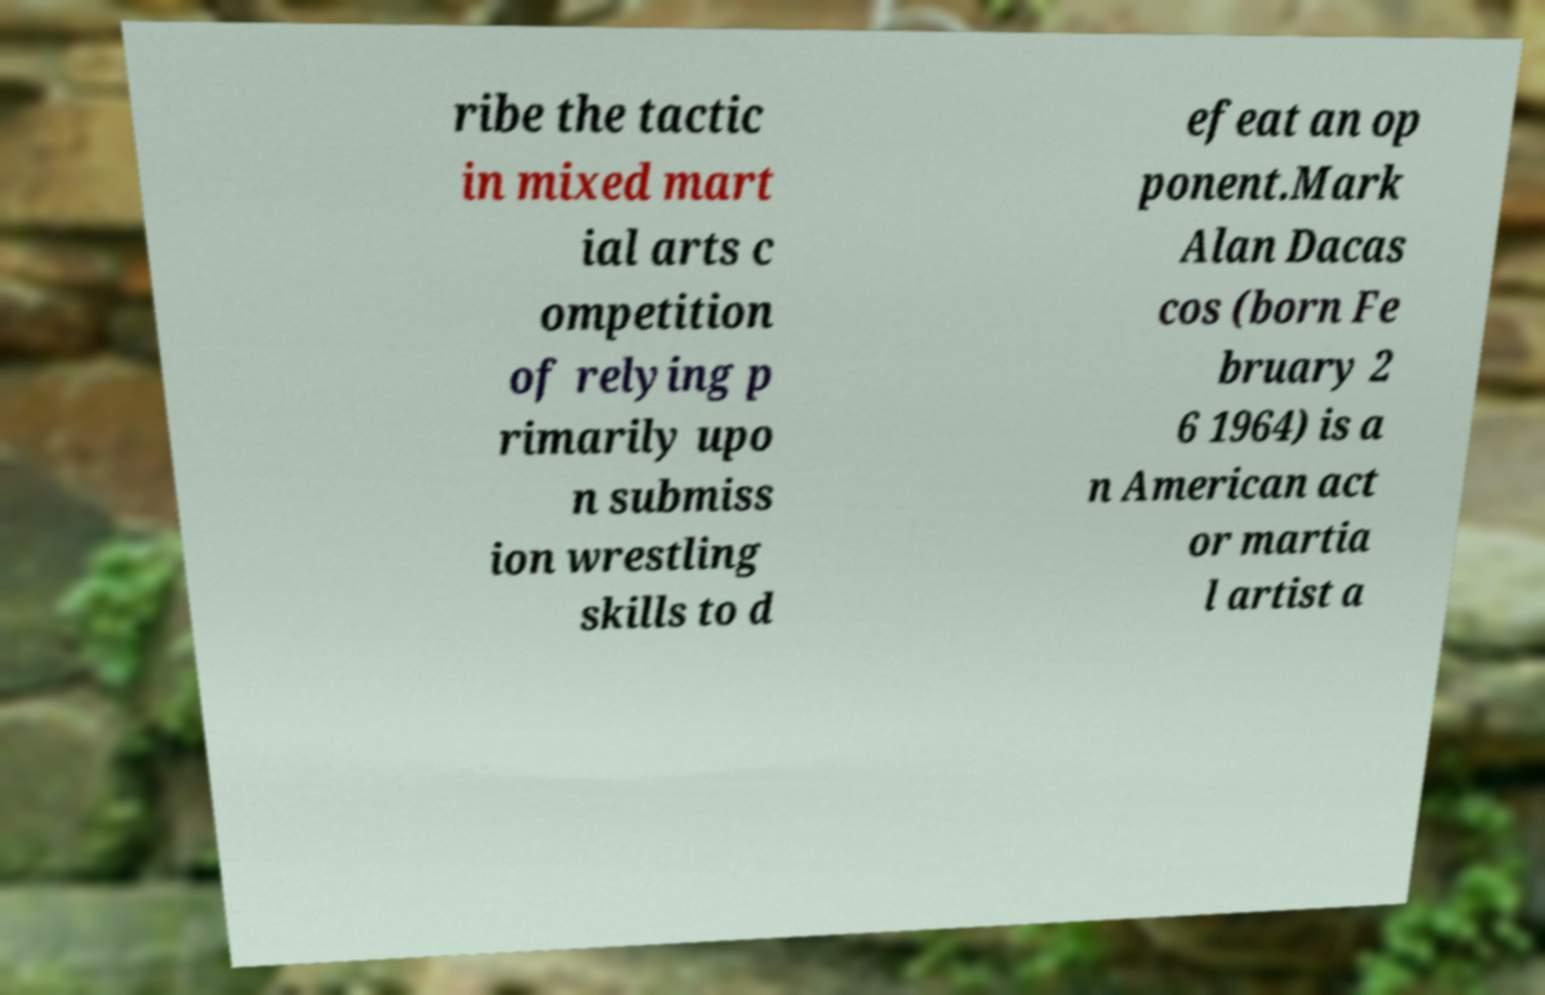What messages or text are displayed in this image? I need them in a readable, typed format. ribe the tactic in mixed mart ial arts c ompetition of relying p rimarily upo n submiss ion wrestling skills to d efeat an op ponent.Mark Alan Dacas cos (born Fe bruary 2 6 1964) is a n American act or martia l artist a 